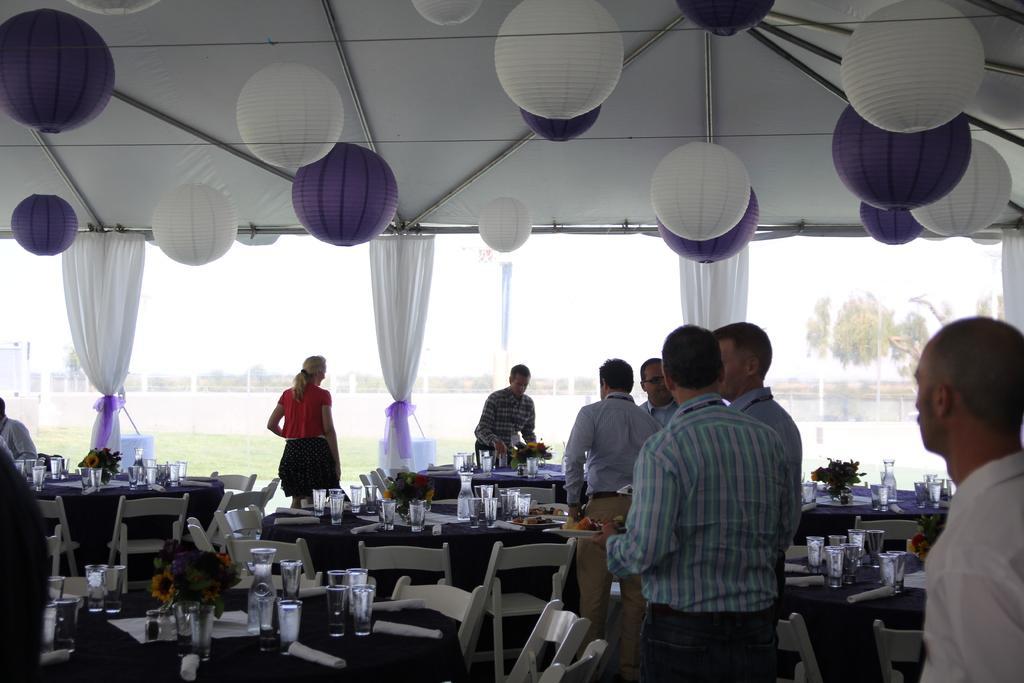Please provide a concise description of this image. In the image we can see few persons were standing. In the center we can see few tables and empty chairs. On table there is a glasses,flower vase and tissue paper. In the background there is a sky curtain,trees,grass and balloons. 